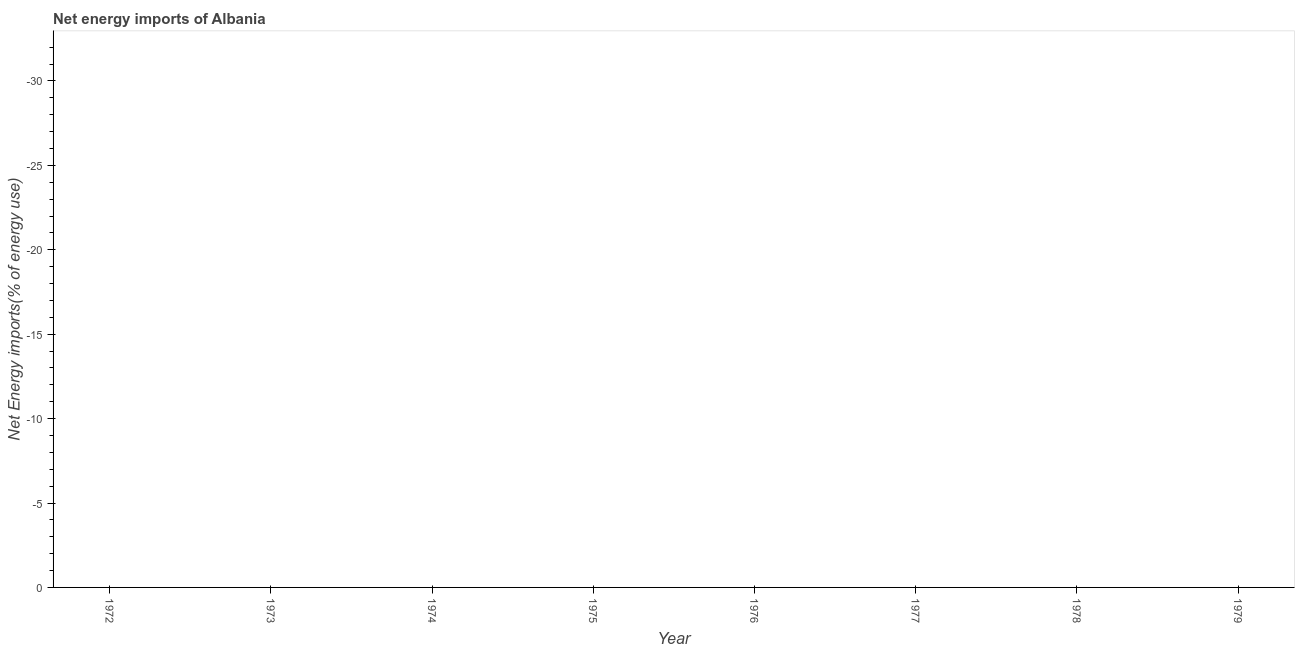Across all years, what is the minimum energy imports?
Offer a terse response. 0. What is the sum of the energy imports?
Your answer should be very brief. 0. What is the median energy imports?
Make the answer very short. 0. How many years are there in the graph?
Keep it short and to the point. 8. Are the values on the major ticks of Y-axis written in scientific E-notation?
Your answer should be compact. No. Does the graph contain any zero values?
Make the answer very short. Yes. Does the graph contain grids?
Ensure brevity in your answer.  No. What is the title of the graph?
Your answer should be very brief. Net energy imports of Albania. What is the label or title of the X-axis?
Your answer should be very brief. Year. What is the label or title of the Y-axis?
Make the answer very short. Net Energy imports(% of energy use). What is the Net Energy imports(% of energy use) in 1972?
Your answer should be compact. 0. What is the Net Energy imports(% of energy use) of 1974?
Offer a terse response. 0. What is the Net Energy imports(% of energy use) in 1975?
Give a very brief answer. 0. What is the Net Energy imports(% of energy use) of 1976?
Your answer should be very brief. 0. What is the Net Energy imports(% of energy use) in 1978?
Offer a very short reply. 0. 